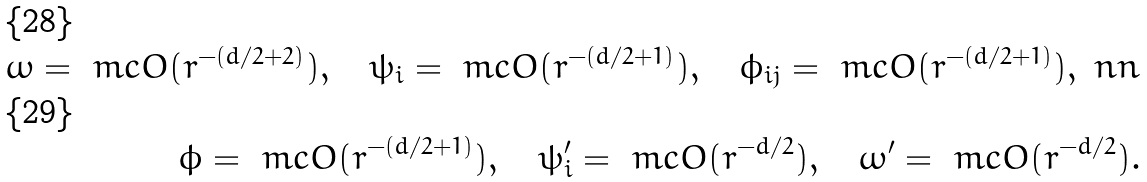Convert formula to latex. <formula><loc_0><loc_0><loc_500><loc_500>\omega = \ m c O ( r ^ { - ( d / 2 + 2 ) } ) , \quad \psi _ { i } = \ m c O ( r ^ { - ( d / 2 + 1 ) } ) , \quad \phi _ { i j } = \ m c O ( r ^ { - ( d / 2 + 1 ) } ) , \ n n \\ \phi = \ m c O ( r ^ { - ( d / 2 + 1 ) } ) , \quad \psi ^ { \prime } _ { i } = \ m c O ( r ^ { - d / 2 } ) , \quad \omega ^ { \prime } = \ m c O ( r ^ { - d / 2 } ) .</formula> 